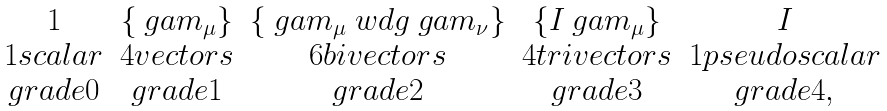Convert formula to latex. <formula><loc_0><loc_0><loc_500><loc_500>\begin{array} { c c c c c } 1 & \{ \ g a m _ { \mu } \} & \{ \ g a m _ { \mu } \ w d g \ g a m _ { \nu } \} & \{ I \ g a m _ { \mu } \} & I \\ 1 s c a l a r & 4 v e c t o r s & 6 b i v e c t o r s & 4 t r i v e c t o r s & 1 p s e u d o s c a l a r \\ g r a d e 0 & g r a d e 1 & g r a d e 2 & g r a d e 3 & g r a d e 4 , \end{array}</formula> 